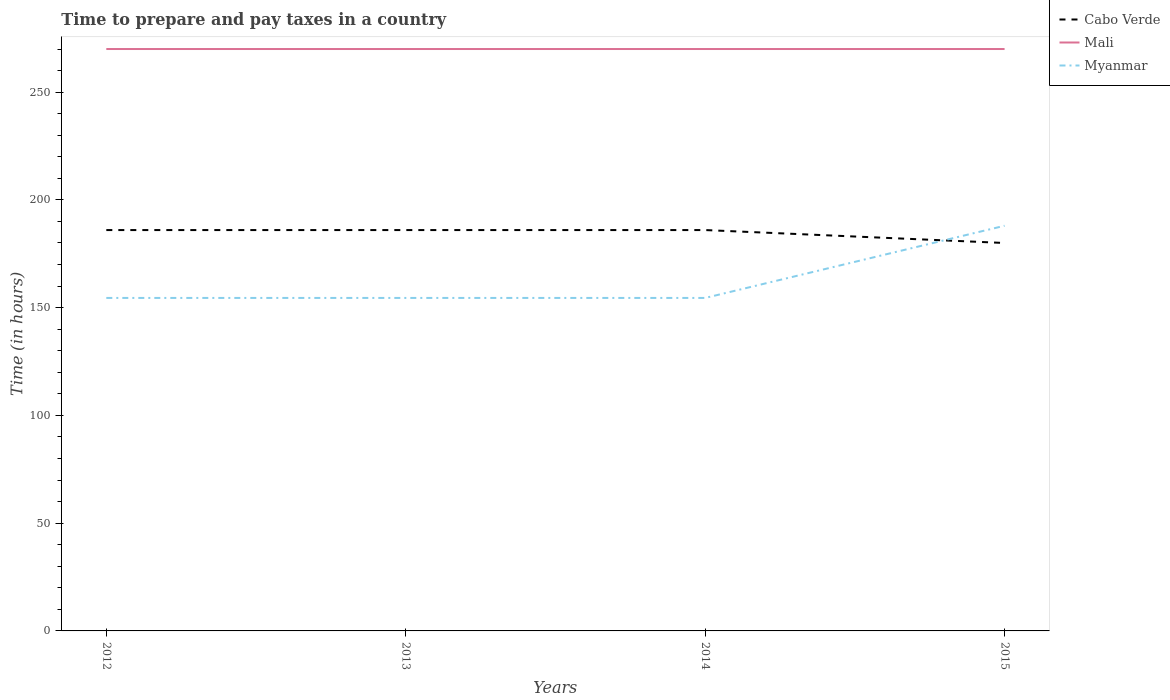Is the number of lines equal to the number of legend labels?
Ensure brevity in your answer.  Yes. Across all years, what is the maximum number of hours required to prepare and pay taxes in Mali?
Offer a very short reply. 270. What is the total number of hours required to prepare and pay taxes in Myanmar in the graph?
Keep it short and to the point. 0. What is the difference between the highest and the second highest number of hours required to prepare and pay taxes in Myanmar?
Your response must be concise. 33.5. Is the number of hours required to prepare and pay taxes in Mali strictly greater than the number of hours required to prepare and pay taxes in Cabo Verde over the years?
Ensure brevity in your answer.  No. Are the values on the major ticks of Y-axis written in scientific E-notation?
Make the answer very short. No. Does the graph contain any zero values?
Make the answer very short. No. How many legend labels are there?
Your answer should be very brief. 3. What is the title of the graph?
Your answer should be compact. Time to prepare and pay taxes in a country. Does "Nepal" appear as one of the legend labels in the graph?
Offer a very short reply. No. What is the label or title of the X-axis?
Make the answer very short. Years. What is the label or title of the Y-axis?
Your answer should be compact. Time (in hours). What is the Time (in hours) of Cabo Verde in 2012?
Ensure brevity in your answer.  186. What is the Time (in hours) of Mali in 2012?
Make the answer very short. 270. What is the Time (in hours) in Myanmar in 2012?
Give a very brief answer. 154.5. What is the Time (in hours) in Cabo Verde in 2013?
Give a very brief answer. 186. What is the Time (in hours) in Mali in 2013?
Your answer should be very brief. 270. What is the Time (in hours) in Myanmar in 2013?
Ensure brevity in your answer.  154.5. What is the Time (in hours) in Cabo Verde in 2014?
Offer a terse response. 186. What is the Time (in hours) in Mali in 2014?
Your response must be concise. 270. What is the Time (in hours) in Myanmar in 2014?
Keep it short and to the point. 154.5. What is the Time (in hours) in Cabo Verde in 2015?
Give a very brief answer. 180. What is the Time (in hours) in Mali in 2015?
Offer a very short reply. 270. What is the Time (in hours) in Myanmar in 2015?
Your response must be concise. 188. Across all years, what is the maximum Time (in hours) in Cabo Verde?
Provide a succinct answer. 186. Across all years, what is the maximum Time (in hours) in Mali?
Provide a short and direct response. 270. Across all years, what is the maximum Time (in hours) in Myanmar?
Ensure brevity in your answer.  188. Across all years, what is the minimum Time (in hours) of Cabo Verde?
Make the answer very short. 180. Across all years, what is the minimum Time (in hours) of Mali?
Your answer should be very brief. 270. Across all years, what is the minimum Time (in hours) in Myanmar?
Provide a succinct answer. 154.5. What is the total Time (in hours) in Cabo Verde in the graph?
Your answer should be very brief. 738. What is the total Time (in hours) in Mali in the graph?
Your answer should be very brief. 1080. What is the total Time (in hours) of Myanmar in the graph?
Your answer should be compact. 651.5. What is the difference between the Time (in hours) in Cabo Verde in 2012 and that in 2013?
Your response must be concise. 0. What is the difference between the Time (in hours) in Myanmar in 2012 and that in 2013?
Your answer should be compact. 0. What is the difference between the Time (in hours) in Cabo Verde in 2012 and that in 2014?
Provide a succinct answer. 0. What is the difference between the Time (in hours) of Mali in 2012 and that in 2014?
Provide a short and direct response. 0. What is the difference between the Time (in hours) of Cabo Verde in 2012 and that in 2015?
Give a very brief answer. 6. What is the difference between the Time (in hours) of Mali in 2012 and that in 2015?
Provide a succinct answer. 0. What is the difference between the Time (in hours) in Myanmar in 2012 and that in 2015?
Make the answer very short. -33.5. What is the difference between the Time (in hours) of Cabo Verde in 2013 and that in 2014?
Your answer should be very brief. 0. What is the difference between the Time (in hours) of Mali in 2013 and that in 2014?
Keep it short and to the point. 0. What is the difference between the Time (in hours) in Myanmar in 2013 and that in 2014?
Give a very brief answer. 0. What is the difference between the Time (in hours) in Cabo Verde in 2013 and that in 2015?
Your response must be concise. 6. What is the difference between the Time (in hours) in Myanmar in 2013 and that in 2015?
Give a very brief answer. -33.5. What is the difference between the Time (in hours) in Cabo Verde in 2014 and that in 2015?
Your answer should be very brief. 6. What is the difference between the Time (in hours) in Mali in 2014 and that in 2015?
Ensure brevity in your answer.  0. What is the difference between the Time (in hours) in Myanmar in 2014 and that in 2015?
Your response must be concise. -33.5. What is the difference between the Time (in hours) of Cabo Verde in 2012 and the Time (in hours) of Mali in 2013?
Provide a succinct answer. -84. What is the difference between the Time (in hours) of Cabo Verde in 2012 and the Time (in hours) of Myanmar in 2013?
Offer a terse response. 31.5. What is the difference between the Time (in hours) of Mali in 2012 and the Time (in hours) of Myanmar in 2013?
Give a very brief answer. 115.5. What is the difference between the Time (in hours) in Cabo Verde in 2012 and the Time (in hours) in Mali in 2014?
Your answer should be compact. -84. What is the difference between the Time (in hours) in Cabo Verde in 2012 and the Time (in hours) in Myanmar in 2014?
Your response must be concise. 31.5. What is the difference between the Time (in hours) in Mali in 2012 and the Time (in hours) in Myanmar in 2014?
Ensure brevity in your answer.  115.5. What is the difference between the Time (in hours) of Cabo Verde in 2012 and the Time (in hours) of Mali in 2015?
Keep it short and to the point. -84. What is the difference between the Time (in hours) of Cabo Verde in 2012 and the Time (in hours) of Myanmar in 2015?
Keep it short and to the point. -2. What is the difference between the Time (in hours) in Cabo Verde in 2013 and the Time (in hours) in Mali in 2014?
Your answer should be compact. -84. What is the difference between the Time (in hours) of Cabo Verde in 2013 and the Time (in hours) of Myanmar in 2014?
Make the answer very short. 31.5. What is the difference between the Time (in hours) of Mali in 2013 and the Time (in hours) of Myanmar in 2014?
Offer a terse response. 115.5. What is the difference between the Time (in hours) in Cabo Verde in 2013 and the Time (in hours) in Mali in 2015?
Your answer should be very brief. -84. What is the difference between the Time (in hours) of Cabo Verde in 2013 and the Time (in hours) of Myanmar in 2015?
Ensure brevity in your answer.  -2. What is the difference between the Time (in hours) in Mali in 2013 and the Time (in hours) in Myanmar in 2015?
Provide a succinct answer. 82. What is the difference between the Time (in hours) in Cabo Verde in 2014 and the Time (in hours) in Mali in 2015?
Provide a short and direct response. -84. What is the difference between the Time (in hours) of Mali in 2014 and the Time (in hours) of Myanmar in 2015?
Ensure brevity in your answer.  82. What is the average Time (in hours) in Cabo Verde per year?
Offer a very short reply. 184.5. What is the average Time (in hours) of Mali per year?
Your answer should be very brief. 270. What is the average Time (in hours) of Myanmar per year?
Your response must be concise. 162.88. In the year 2012, what is the difference between the Time (in hours) in Cabo Verde and Time (in hours) in Mali?
Ensure brevity in your answer.  -84. In the year 2012, what is the difference between the Time (in hours) in Cabo Verde and Time (in hours) in Myanmar?
Ensure brevity in your answer.  31.5. In the year 2012, what is the difference between the Time (in hours) in Mali and Time (in hours) in Myanmar?
Make the answer very short. 115.5. In the year 2013, what is the difference between the Time (in hours) of Cabo Verde and Time (in hours) of Mali?
Provide a short and direct response. -84. In the year 2013, what is the difference between the Time (in hours) in Cabo Verde and Time (in hours) in Myanmar?
Keep it short and to the point. 31.5. In the year 2013, what is the difference between the Time (in hours) of Mali and Time (in hours) of Myanmar?
Provide a short and direct response. 115.5. In the year 2014, what is the difference between the Time (in hours) of Cabo Verde and Time (in hours) of Mali?
Provide a short and direct response. -84. In the year 2014, what is the difference between the Time (in hours) of Cabo Verde and Time (in hours) of Myanmar?
Provide a succinct answer. 31.5. In the year 2014, what is the difference between the Time (in hours) in Mali and Time (in hours) in Myanmar?
Your answer should be very brief. 115.5. In the year 2015, what is the difference between the Time (in hours) of Cabo Verde and Time (in hours) of Mali?
Your answer should be very brief. -90. In the year 2015, what is the difference between the Time (in hours) of Mali and Time (in hours) of Myanmar?
Make the answer very short. 82. What is the ratio of the Time (in hours) in Cabo Verde in 2012 to that in 2013?
Ensure brevity in your answer.  1. What is the ratio of the Time (in hours) of Cabo Verde in 2012 to that in 2014?
Your answer should be very brief. 1. What is the ratio of the Time (in hours) of Mali in 2012 to that in 2014?
Offer a terse response. 1. What is the ratio of the Time (in hours) in Cabo Verde in 2012 to that in 2015?
Offer a terse response. 1.03. What is the ratio of the Time (in hours) in Mali in 2012 to that in 2015?
Your response must be concise. 1. What is the ratio of the Time (in hours) in Myanmar in 2012 to that in 2015?
Make the answer very short. 0.82. What is the ratio of the Time (in hours) of Cabo Verde in 2013 to that in 2014?
Make the answer very short. 1. What is the ratio of the Time (in hours) in Mali in 2013 to that in 2014?
Give a very brief answer. 1. What is the ratio of the Time (in hours) in Cabo Verde in 2013 to that in 2015?
Offer a very short reply. 1.03. What is the ratio of the Time (in hours) in Myanmar in 2013 to that in 2015?
Keep it short and to the point. 0.82. What is the ratio of the Time (in hours) of Cabo Verde in 2014 to that in 2015?
Offer a very short reply. 1.03. What is the ratio of the Time (in hours) of Myanmar in 2014 to that in 2015?
Offer a terse response. 0.82. What is the difference between the highest and the second highest Time (in hours) in Myanmar?
Give a very brief answer. 33.5. What is the difference between the highest and the lowest Time (in hours) in Myanmar?
Give a very brief answer. 33.5. 